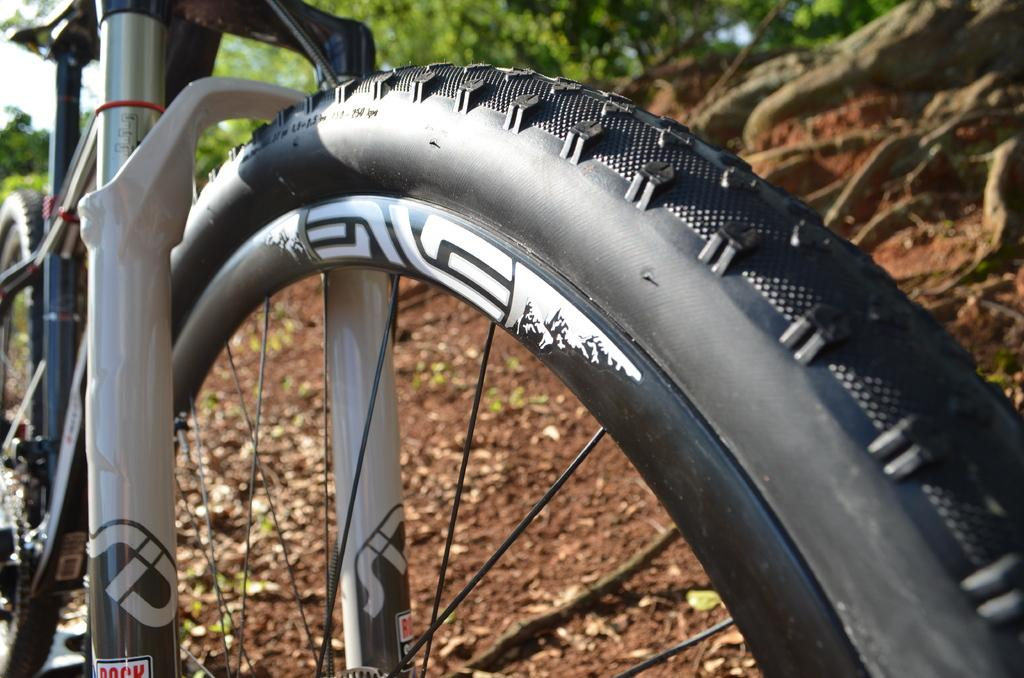What is the main object in the image? There is a bicycle in the image. What type of natural elements can be seen in the image? There are rocks and trees visible in the image. What part of the sky is visible in the image? The sky is visible in the top left corner of the image. What type of account is being discussed in the image? There is no account being discussed in the image; it features a bicycle, rocks, trees, and a portion of the sky. Can you see any books or a library in the image? There are no books or a library present in the image. 